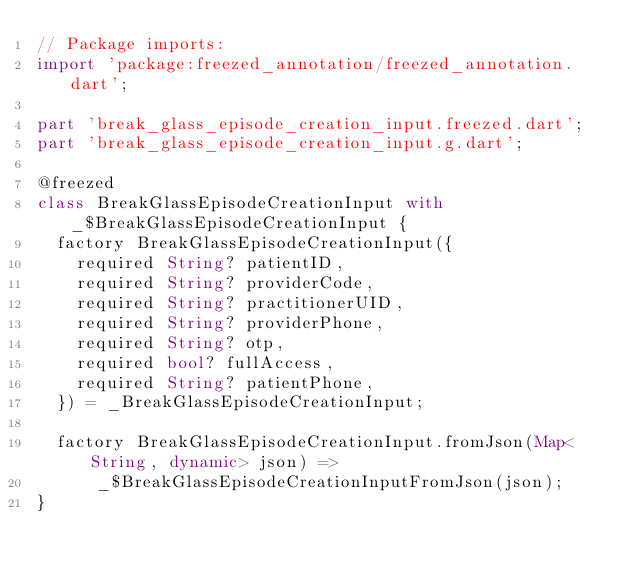Convert code to text. <code><loc_0><loc_0><loc_500><loc_500><_Dart_>// Package imports:
import 'package:freezed_annotation/freezed_annotation.dart';

part 'break_glass_episode_creation_input.freezed.dart';
part 'break_glass_episode_creation_input.g.dart';

@freezed
class BreakGlassEpisodeCreationInput with _$BreakGlassEpisodeCreationInput {
  factory BreakGlassEpisodeCreationInput({
    required String? patientID,
    required String? providerCode,
    required String? practitionerUID,
    required String? providerPhone,
    required String? otp,
    required bool? fullAccess,
    required String? patientPhone,
  }) = _BreakGlassEpisodeCreationInput;

  factory BreakGlassEpisodeCreationInput.fromJson(Map<String, dynamic> json) =>
      _$BreakGlassEpisodeCreationInputFromJson(json);
}
</code> 